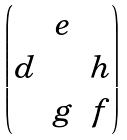<formula> <loc_0><loc_0><loc_500><loc_500>\begin{pmatrix} & e & \\ d & & h \\ & g & f \end{pmatrix}</formula> 